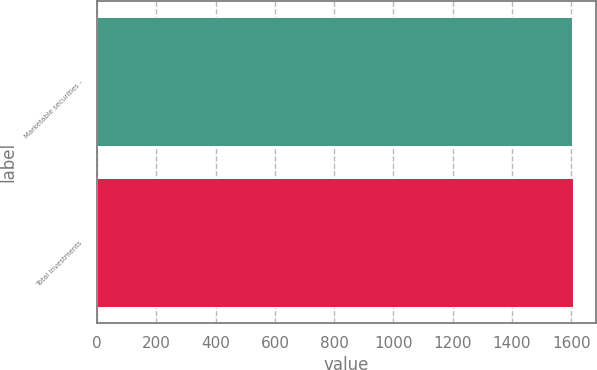Convert chart. <chart><loc_0><loc_0><loc_500><loc_500><bar_chart><fcel>Marketable securities -<fcel>Total investments<nl><fcel>1604<fcel>1604.1<nl></chart> 